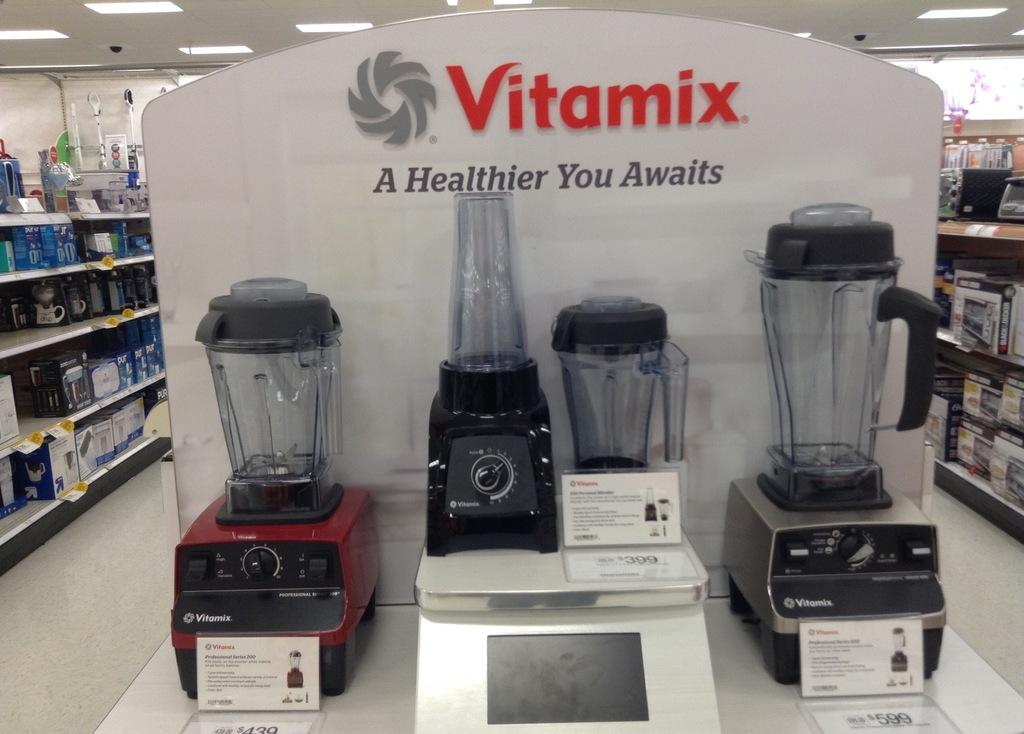<image>
Provide a brief description of the given image. A display of Vitamix blenders sits on an end display in a store 